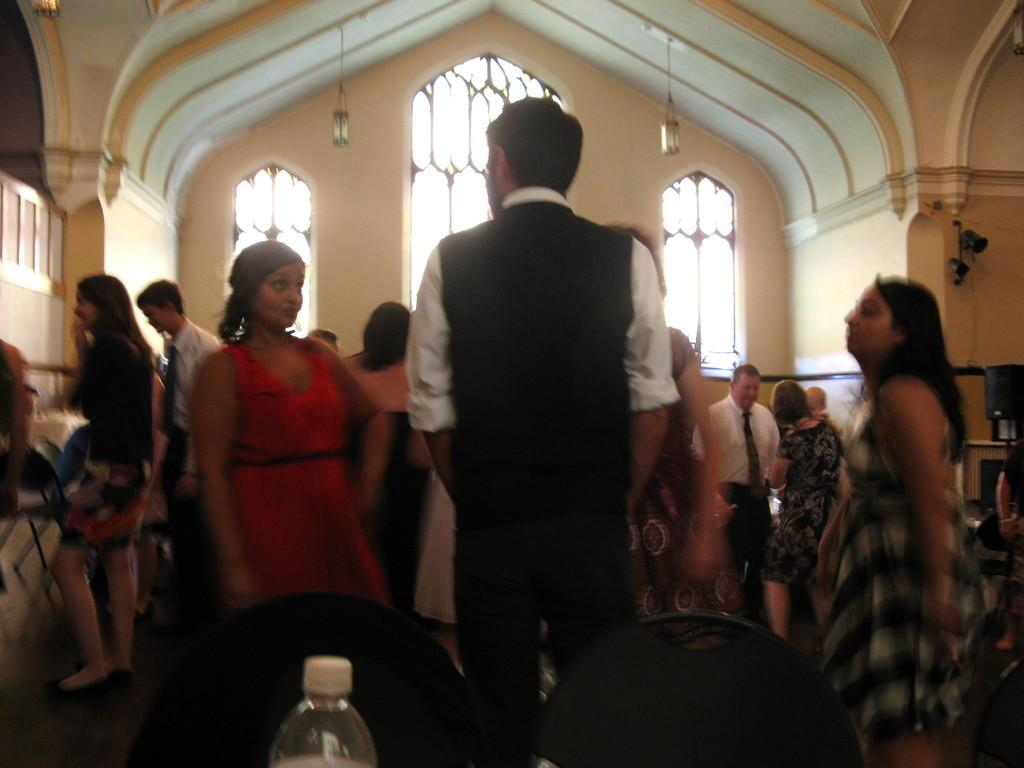How many people are in the image? There is a group of people in the image, but the exact number is not specified. What are the people in the image doing? The people are standing in the image. What can be seen in the background of the image? There is a window and lamps in the background of the image. Reasoning: Let's think step by following the guidelines to produce the conversation. We start by identifying the main subject of the image, which is the group of people. Then, we describe what the people are doing, which is standing. Finally, we mention the background elements, which are the window and lamps. We avoid asking questions that cannot be answered definitively and ensure that the language is simple and clear. Absurd Question/Answer: What type of curtain can be seen blowing in the wind in the image? There is no curtain or wind present in the image. What type of destruction can be seen in the image? There is no destruction present in the image; it features a group of people standing with a window and lamps in the background. 